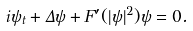Convert formula to latex. <formula><loc_0><loc_0><loc_500><loc_500>i \psi _ { t } + \Delta \psi + F ^ { \prime } ( | \psi | ^ { 2 } ) \psi = 0 .</formula> 